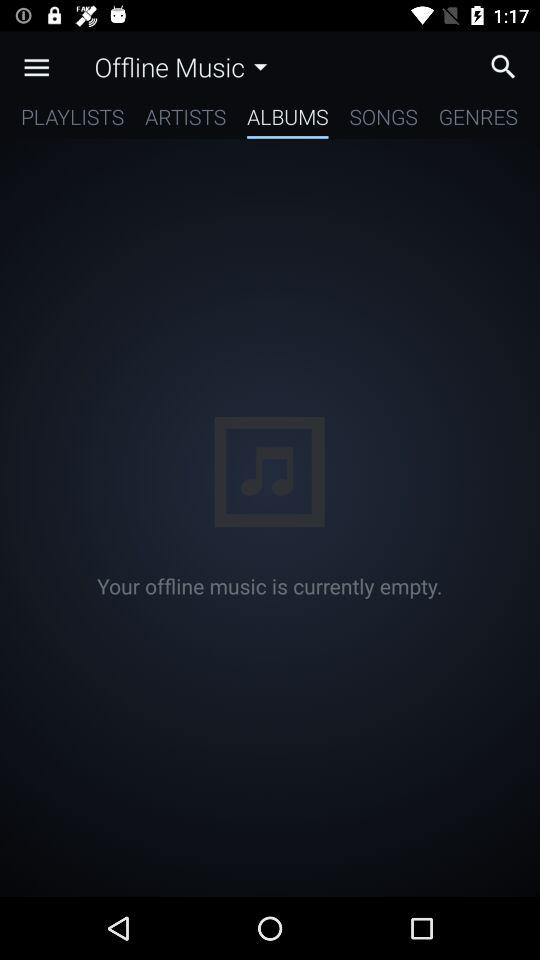Which tab am I on? You are on the "ALBUMS" tab. 